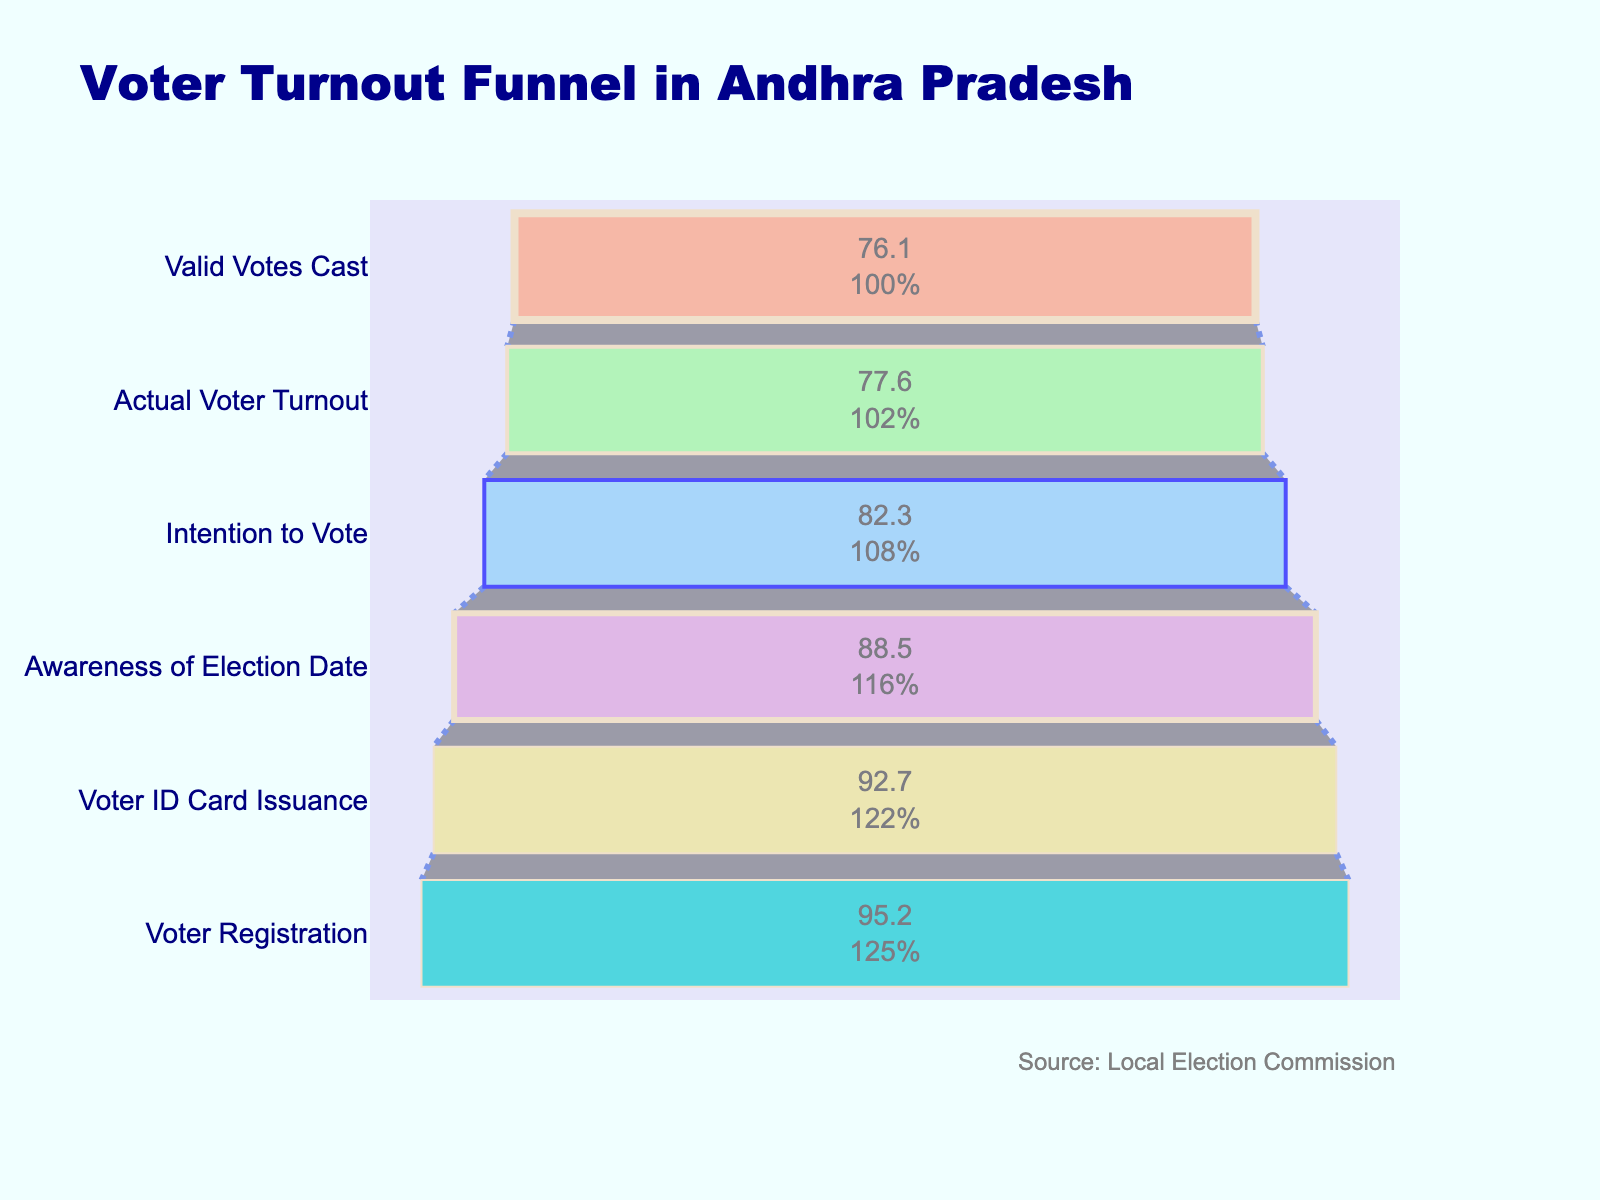What is the title of the funnel chart? The title of the funnel chart is provided at the top of the figure. It usually summarizes the main topic of the chart.
Answer: Voter Turnout Funnel in Andhra Pradesh How many stages are represented in the funnel chart? Count the number of unique stages listed on the y-axis of the funnel chart.
Answer: Six What is the percentage of Voter ID Card Issuance? Find the value associated with the "Voter ID Card Issuance" stage on the y-axis.
Answer: 92.7% What is the largest drop in percentage between any two consecutive stages? Calculate the differences between consecutive percentages to find the largest drop. The drops are 2.5 (95.2 - 92.7), 4.2 (92.7 - 88.5), 6.2 (88.5 - 82.3), 4.7 (82.3 - 77.6), and 1.5 (77.6 - 76.1).
Answer: 6.2% Which stage has the smallest percentage? Look at all the stages in the funnel and identify the smallest percentage value.
Answer: Valid Votes Cast By what percentage does Actual Voter Turnout differ from Intention to Vote? Subtract the Actual Voter Turnout percentage from the Intention to Vote percentage. The difference is 82.3 - 77.6.
Answer: 4.7% What is the percentage of registered voters compared to those who were aware of the election date? Compare the percentage for "Voter Registration" with "Awareness of Election Date". Registration is 95.2% and awareness is 88.5%.
Answer: 6.7% higher What is the overall change in percentage from Voter Registration to Valid Votes Cast? Subtract the Valid Votes Cast percentage from the Voter Registration percentage. The initial value is 95.2% and the final value is 76.1%.
Answer: 19.1% Which two stages have the closest percentages? Compare the differences between consecutive percentages to find the smallest difference. The smallest difference is between Actual Voter Turnout (77.6%) and Valid Votes Cast (76.1%), which is 1.5%.
Answer: Actual Voter Turnout and Valid Votes Cast How does the intention to vote compare with the awareness of election date? Compare the percentages of the two stages. Awareness of Election Date is 88.5%, and Intention to Vote is 82.3%.
Answer: 6.2% lower 